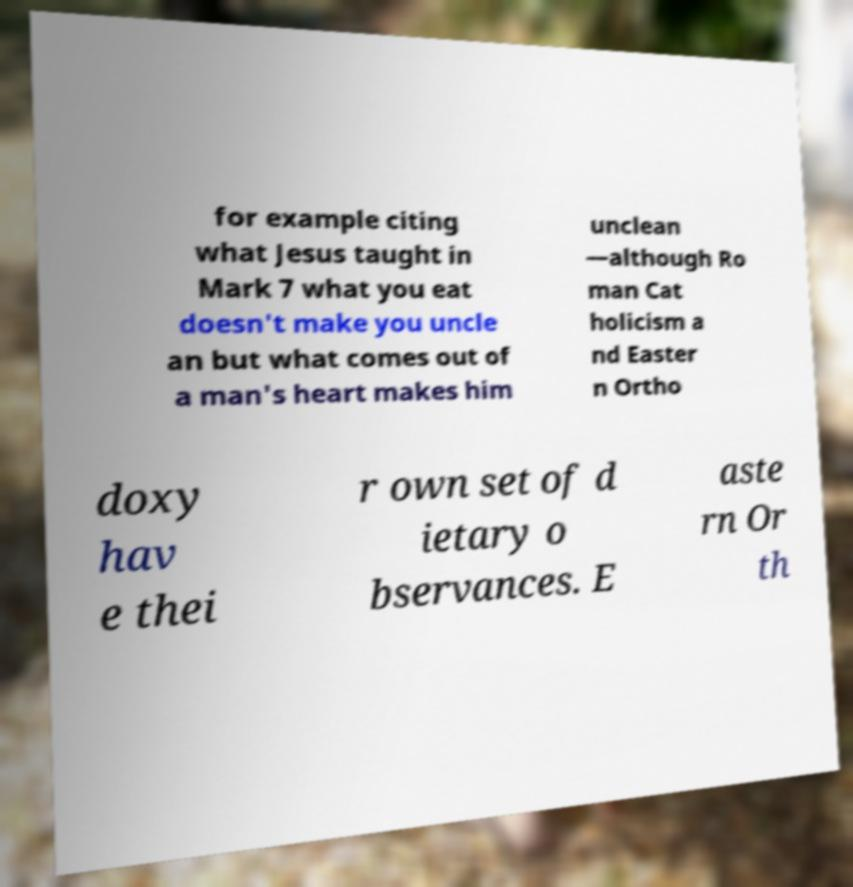Could you extract and type out the text from this image? for example citing what Jesus taught in Mark 7 what you eat doesn't make you uncle an but what comes out of a man's heart makes him unclean —although Ro man Cat holicism a nd Easter n Ortho doxy hav e thei r own set of d ietary o bservances. E aste rn Or th 